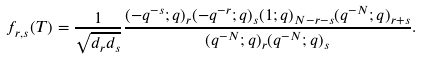<formula> <loc_0><loc_0><loc_500><loc_500>f _ { r , s } ( T ) = \frac { 1 } { \sqrt { d _ { r } d _ { s } } } \frac { ( - q ^ { - s } ; q ) _ { r } ( - q ^ { - r } ; q ) _ { s } ( 1 ; q ) _ { N - r - s } ( q ^ { - N } ; q ) _ { r + s } } { ( q ^ { - N } ; q ) _ { r } ( q ^ { - N } ; q ) _ { s } } .</formula> 